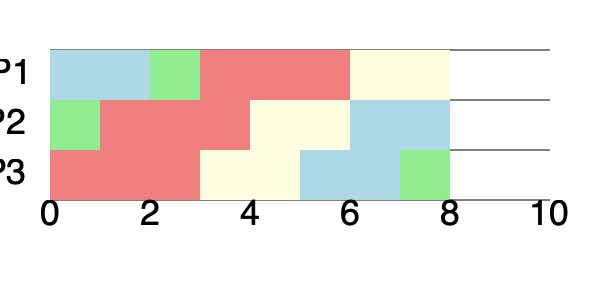Given the Gantt chart above representing the execution of three processes (P1, P2, and P3) using a CPU scheduling algorithm, calculate the average turnaround time for all processes. Assume that all processes arrive at time 0. To calculate the average turnaround time, we need to follow these steps:

1. Identify the completion time for each process:
   P1: Completes at t = 9
   P2: Completes at t = 8
   P3: Completes at t = 9

2. Calculate the turnaround time for each process:
   Turnaround time = Completion time - Arrival time
   Since all processes arrive at t = 0:
   P1: 9 - 0 = 9
   P2: 8 - 0 = 8
   P3: 9 - 0 = 9

3. Calculate the sum of all turnaround times:
   Total turnaround time = 9 + 8 + 9 = 26

4. Calculate the average turnaround time:
   Average turnaround time = Total turnaround time / Number of processes
   $$ \text{Average turnaround time} = \frac{26}{3} = \frac{26}{3} $$

Therefore, the average turnaround time for all processes is $\frac{26}{3}$ time units.
Answer: $\frac{26}{3}$ time units 